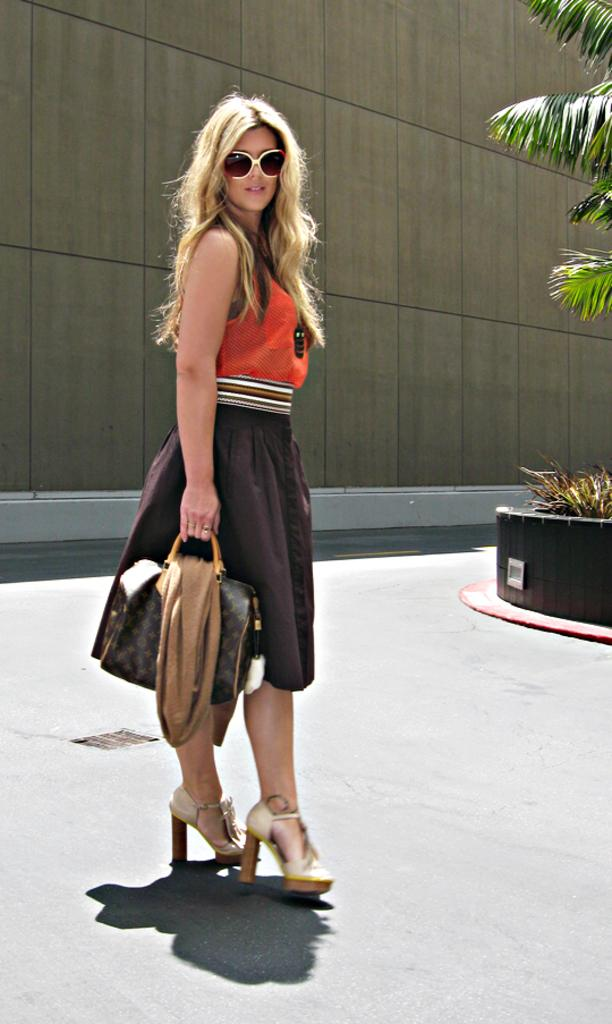What is the main subject of the image? The main subject of the image is a woman. What is the woman doing in the image? The woman is standing in the image. What is the woman holding in the image? The woman is holding a handbag in the image. What is the woman wearing on her face in the image? The woman is wearing goggles in the image. What type of vegetation is on the right side of the image? There are trees and plants on the right side of the image. What type of bead is the woman using to make a selection in the image? There is no bead present in the image, and the woman is not making any selections. 